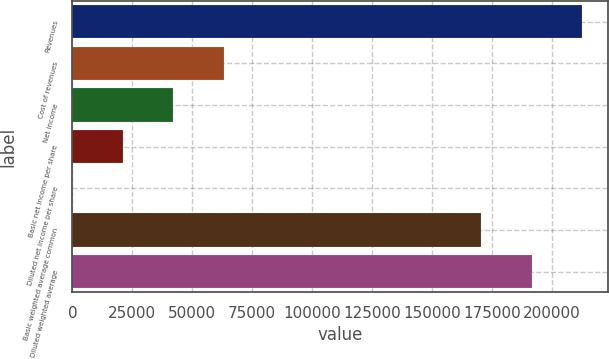<chart> <loc_0><loc_0><loc_500><loc_500><bar_chart><fcel>Revenues<fcel>Cost of revenues<fcel>Net income<fcel>Basic net income per share<fcel>Diluted net income per share<fcel>Basic weighted average common<fcel>Diluted weighted average<nl><fcel>212593<fcel>63110.5<fcel>42073.8<fcel>21037<fcel>0.2<fcel>170519<fcel>191556<nl></chart> 